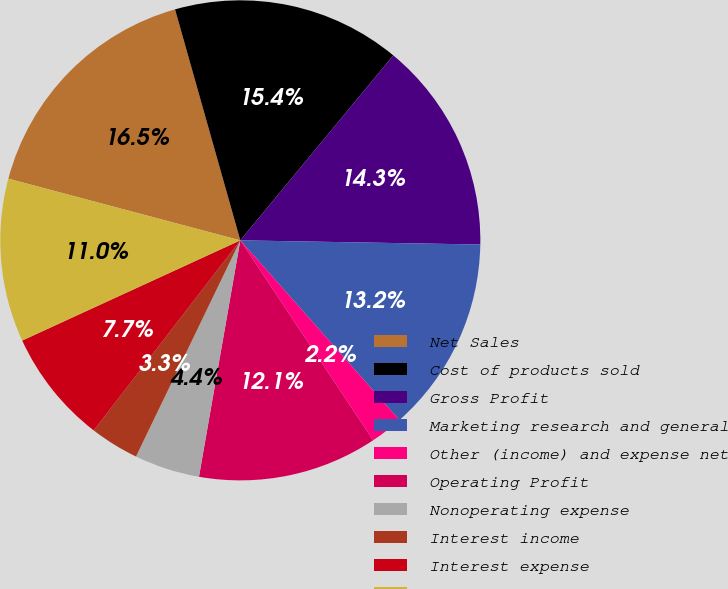Convert chart to OTSL. <chart><loc_0><loc_0><loc_500><loc_500><pie_chart><fcel>Net Sales<fcel>Cost of products sold<fcel>Gross Profit<fcel>Marketing research and general<fcel>Other (income) and expense net<fcel>Operating Profit<fcel>Nonoperating expense<fcel>Interest income<fcel>Interest expense<fcel>Income Before Income Taxes<nl><fcel>16.48%<fcel>15.38%<fcel>14.28%<fcel>13.19%<fcel>2.2%<fcel>12.09%<fcel>4.4%<fcel>3.3%<fcel>7.69%<fcel>10.99%<nl></chart> 